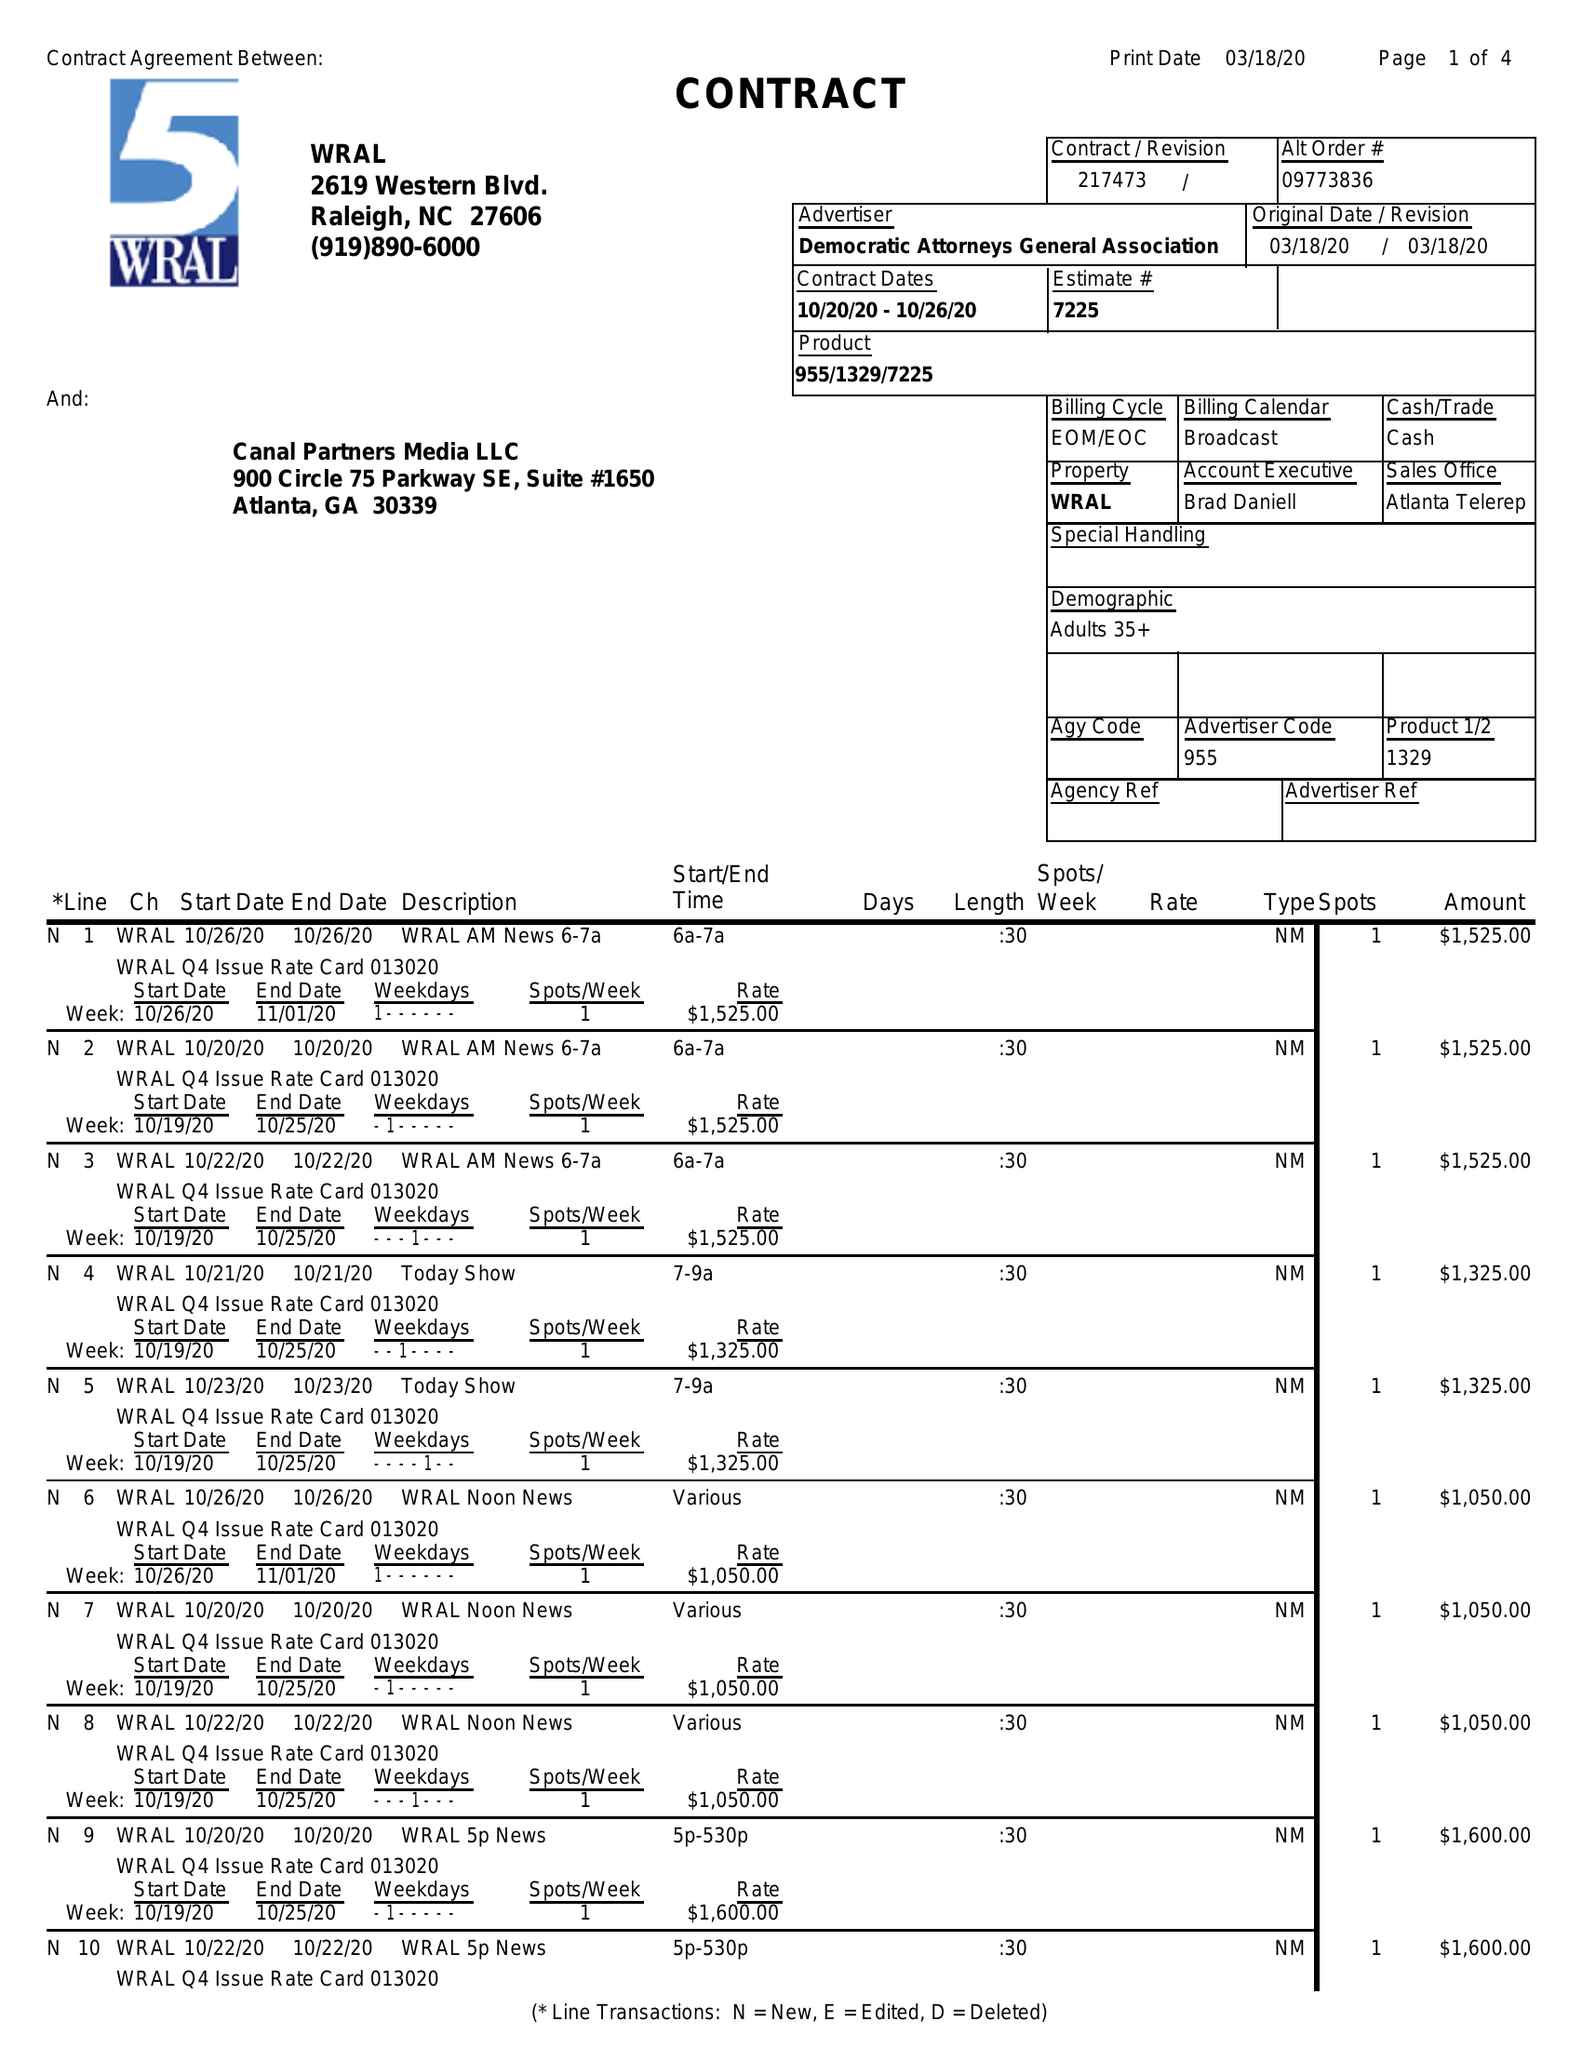What is the value for the contract_num?
Answer the question using a single word or phrase. 217473 